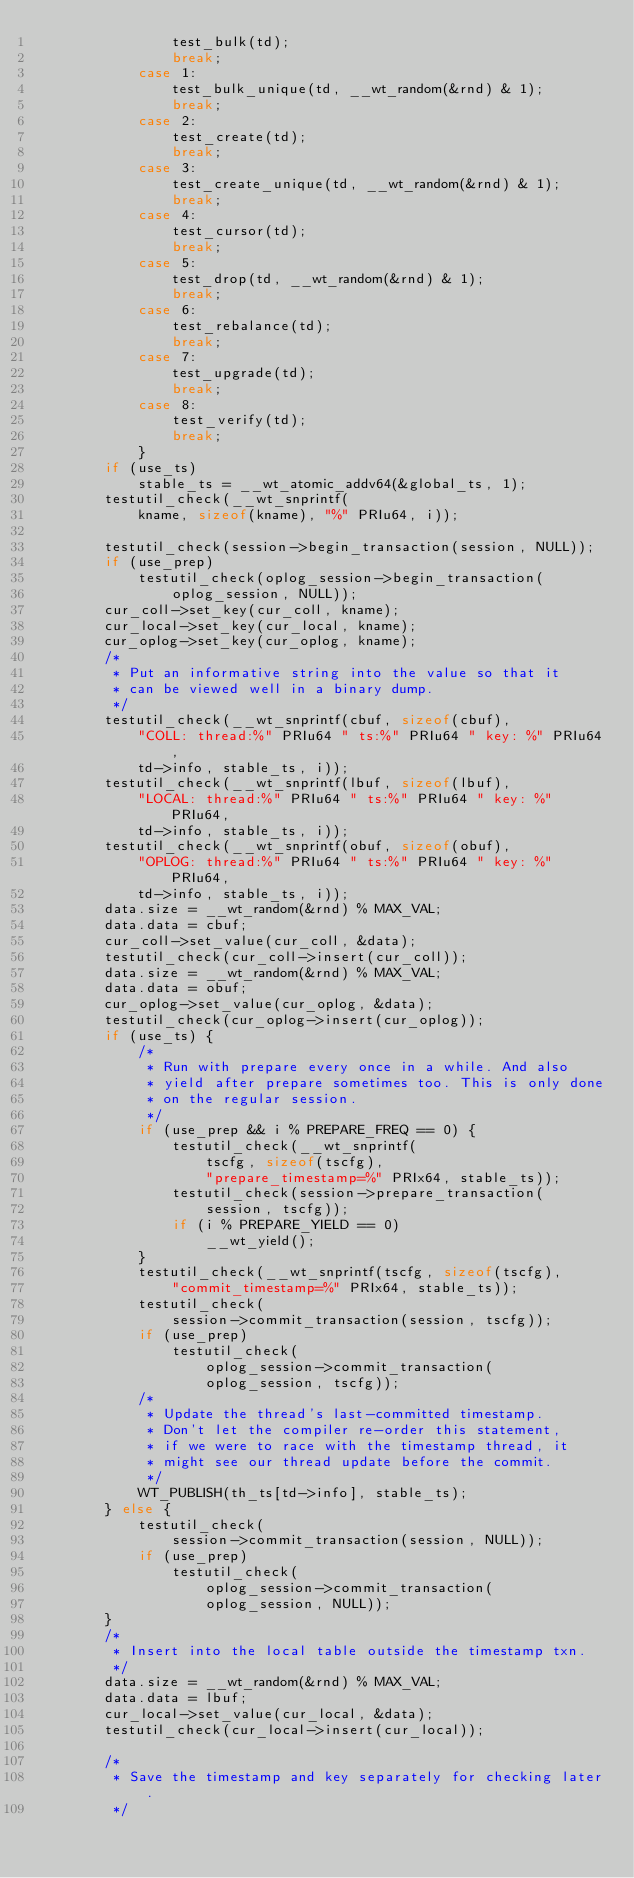Convert code to text. <code><loc_0><loc_0><loc_500><loc_500><_C_>				test_bulk(td);
				break;
			case 1:
				test_bulk_unique(td, __wt_random(&rnd) & 1);
				break;
			case 2:
				test_create(td);
				break;
			case 3:
				test_create_unique(td, __wt_random(&rnd) & 1);
				break;
			case 4:
				test_cursor(td);
				break;
			case 5:
				test_drop(td, __wt_random(&rnd) & 1);
				break;
			case 6:
				test_rebalance(td);
				break;
			case 7:
				test_upgrade(td);
				break;
			case 8:
				test_verify(td);
				break;
			}
		if (use_ts)
			stable_ts = __wt_atomic_addv64(&global_ts, 1);
		testutil_check(__wt_snprintf(
		    kname, sizeof(kname), "%" PRIu64, i));

		testutil_check(session->begin_transaction(session, NULL));
		if (use_prep)
			testutil_check(oplog_session->begin_transaction(
			    oplog_session, NULL));
		cur_coll->set_key(cur_coll, kname);
		cur_local->set_key(cur_local, kname);
		cur_oplog->set_key(cur_oplog, kname);
		/*
		 * Put an informative string into the value so that it
		 * can be viewed well in a binary dump.
		 */
		testutil_check(__wt_snprintf(cbuf, sizeof(cbuf),
		    "COLL: thread:%" PRIu64 " ts:%" PRIu64 " key: %" PRIu64,
		    td->info, stable_ts, i));
		testutil_check(__wt_snprintf(lbuf, sizeof(lbuf),
		    "LOCAL: thread:%" PRIu64 " ts:%" PRIu64 " key: %" PRIu64,
		    td->info, stable_ts, i));
		testutil_check(__wt_snprintf(obuf, sizeof(obuf),
		    "OPLOG: thread:%" PRIu64 " ts:%" PRIu64 " key: %" PRIu64,
		    td->info, stable_ts, i));
		data.size = __wt_random(&rnd) % MAX_VAL;
		data.data = cbuf;
		cur_coll->set_value(cur_coll, &data);
		testutil_check(cur_coll->insert(cur_coll));
		data.size = __wt_random(&rnd) % MAX_VAL;
		data.data = obuf;
		cur_oplog->set_value(cur_oplog, &data);
		testutil_check(cur_oplog->insert(cur_oplog));
		if (use_ts) {
			/*
			 * Run with prepare every once in a while. And also
			 * yield after prepare sometimes too. This is only done
			 * on the regular session.
			 */
			if (use_prep && i % PREPARE_FREQ == 0) {
				testutil_check(__wt_snprintf(
				    tscfg, sizeof(tscfg),
				    "prepare_timestamp=%" PRIx64, stable_ts));
				testutil_check(session->prepare_transaction(
				    session, tscfg));
				if (i % PREPARE_YIELD == 0)
					__wt_yield();
			}
			testutil_check(__wt_snprintf(tscfg, sizeof(tscfg),
			    "commit_timestamp=%" PRIx64, stable_ts));
			testutil_check(
			    session->commit_transaction(session, tscfg));
			if (use_prep)
				testutil_check(
				    oplog_session->commit_transaction(
				    oplog_session, tscfg));
			/*
			 * Update the thread's last-committed timestamp.
			 * Don't let the compiler re-order this statement,
			 * if we were to race with the timestamp thread, it
			 * might see our thread update before the commit.
			 */
			WT_PUBLISH(th_ts[td->info], stable_ts);
		} else {
			testutil_check(
			    session->commit_transaction(session, NULL));
			if (use_prep)
				testutil_check(
				    oplog_session->commit_transaction(
				    oplog_session, NULL));
		}
		/*
		 * Insert into the local table outside the timestamp txn.
		 */
		data.size = __wt_random(&rnd) % MAX_VAL;
		data.data = lbuf;
		cur_local->set_value(cur_local, &data);
		testutil_check(cur_local->insert(cur_local));

		/*
		 * Save the timestamp and key separately for checking later.
		 */</code> 